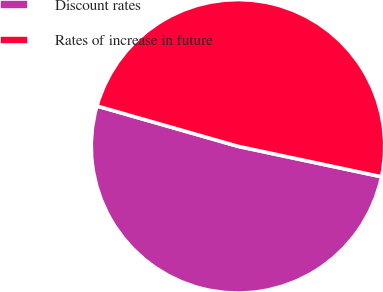Convert chart to OTSL. <chart><loc_0><loc_0><loc_500><loc_500><pie_chart><fcel>Discount rates<fcel>Rates of increase in future<nl><fcel>51.11%<fcel>48.89%<nl></chart> 